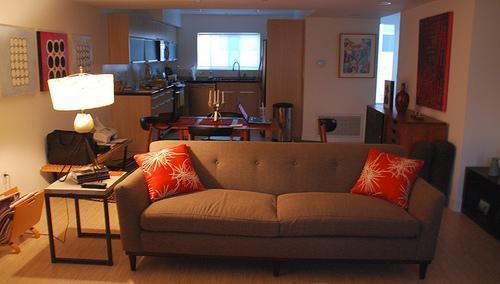How many lamps are visible?
Give a very brief answer. 1. 